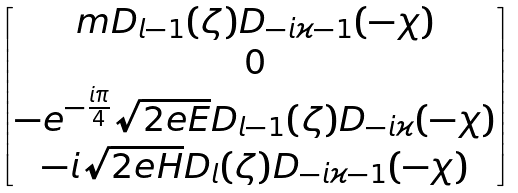<formula> <loc_0><loc_0><loc_500><loc_500>\begin{bmatrix} m D _ { l - 1 } ( \zeta ) D _ { - i \varkappa - 1 } ( - \chi ) \\ 0 \\ - e ^ { - \frac { i \pi } 4 } \sqrt { 2 e E } D _ { l - 1 } ( \zeta ) D _ { - i \varkappa } ( - \chi ) \\ - i \sqrt { 2 e H } D _ { l } ( \zeta ) D _ { - i \varkappa - 1 } ( - \chi ) \end{bmatrix}</formula> 